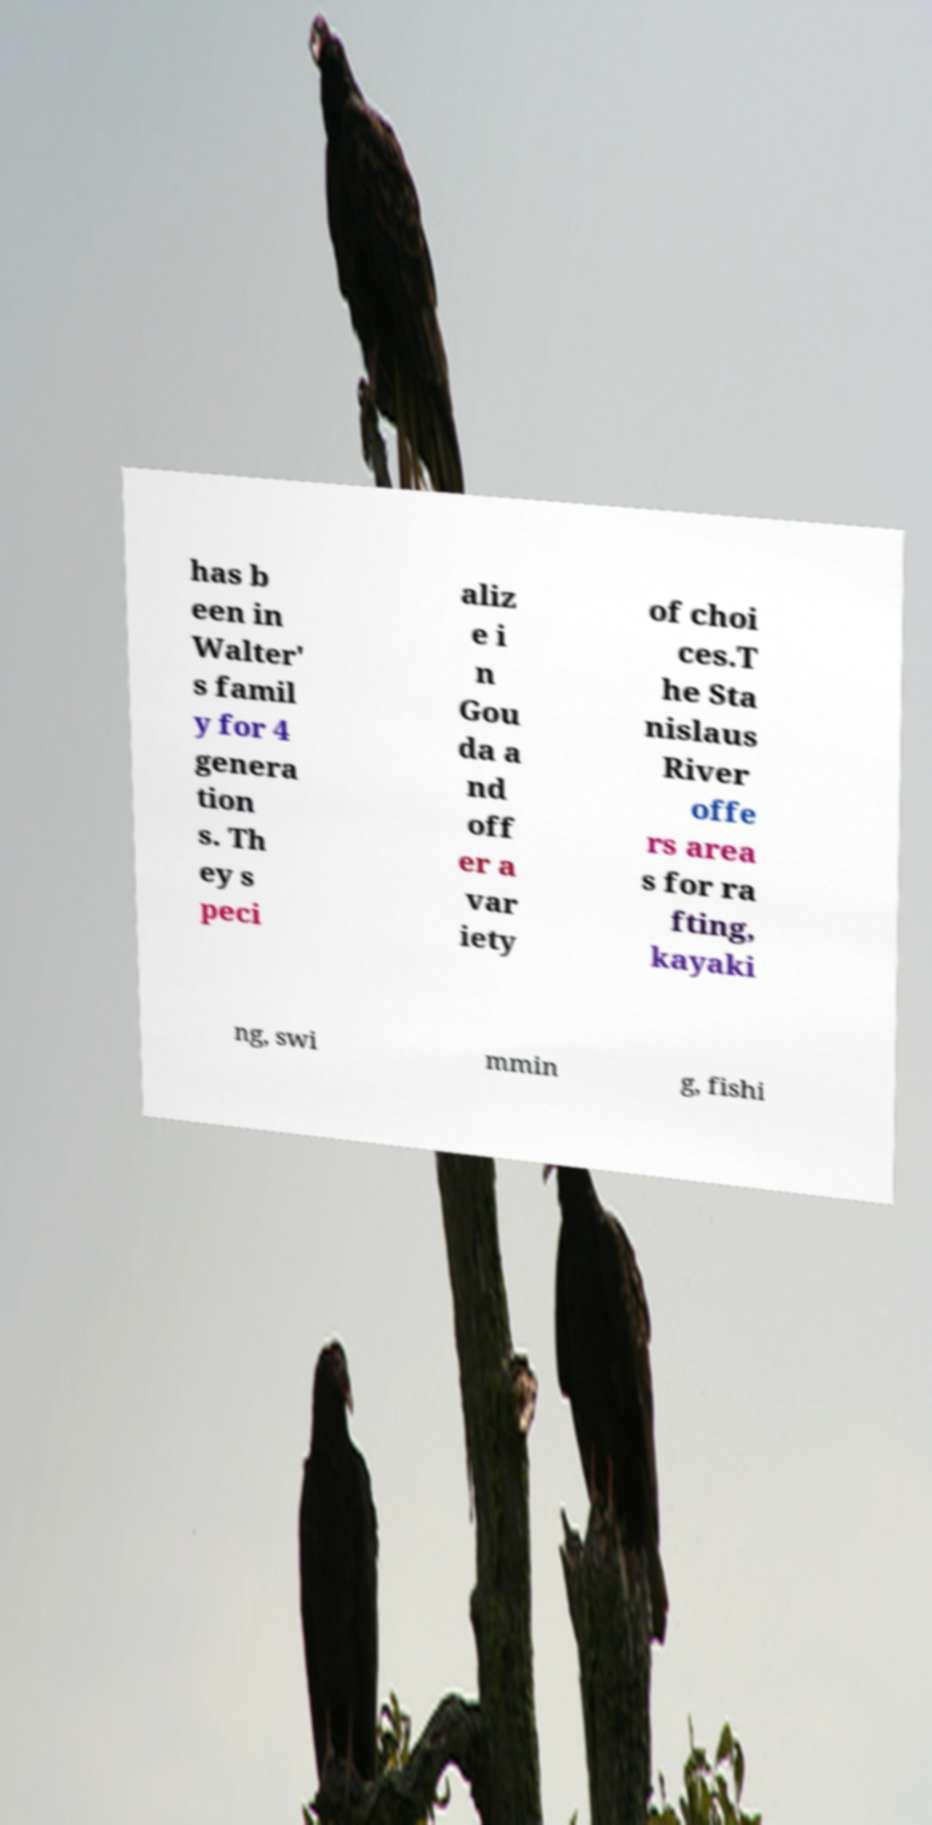For documentation purposes, I need the text within this image transcribed. Could you provide that? has b een in Walter' s famil y for 4 genera tion s. Th ey s peci aliz e i n Gou da a nd off er a var iety of choi ces.T he Sta nislaus River offe rs area s for ra fting, kayaki ng, swi mmin g, fishi 